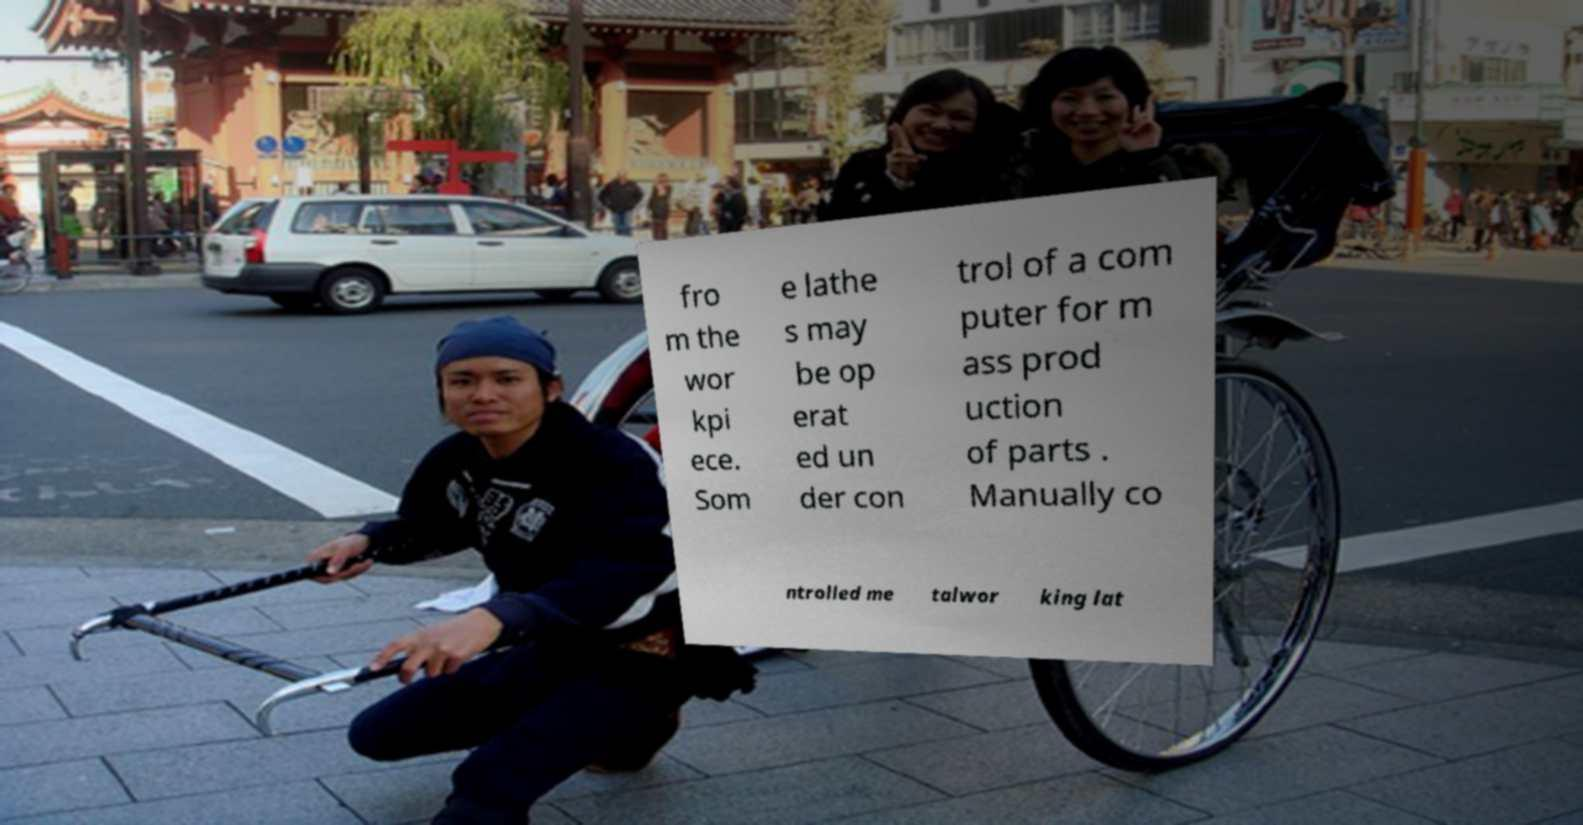Can you accurately transcribe the text from the provided image for me? fro m the wor kpi ece. Som e lathe s may be op erat ed un der con trol of a com puter for m ass prod uction of parts . Manually co ntrolled me talwor king lat 